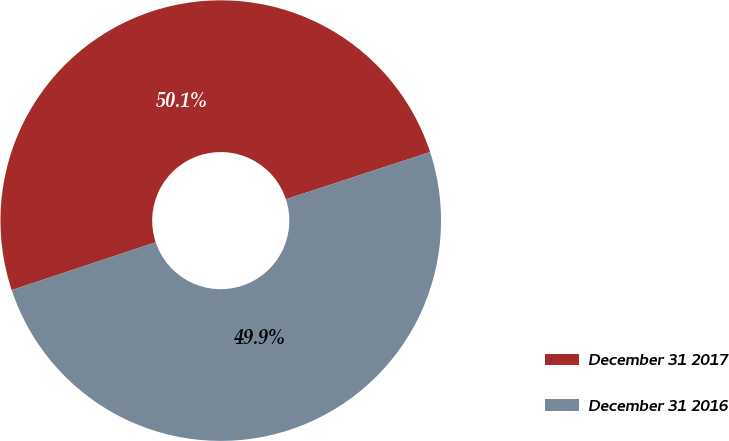Convert chart to OTSL. <chart><loc_0><loc_0><loc_500><loc_500><pie_chart><fcel>December 31 2017<fcel>December 31 2016<nl><fcel>50.07%<fcel>49.93%<nl></chart> 